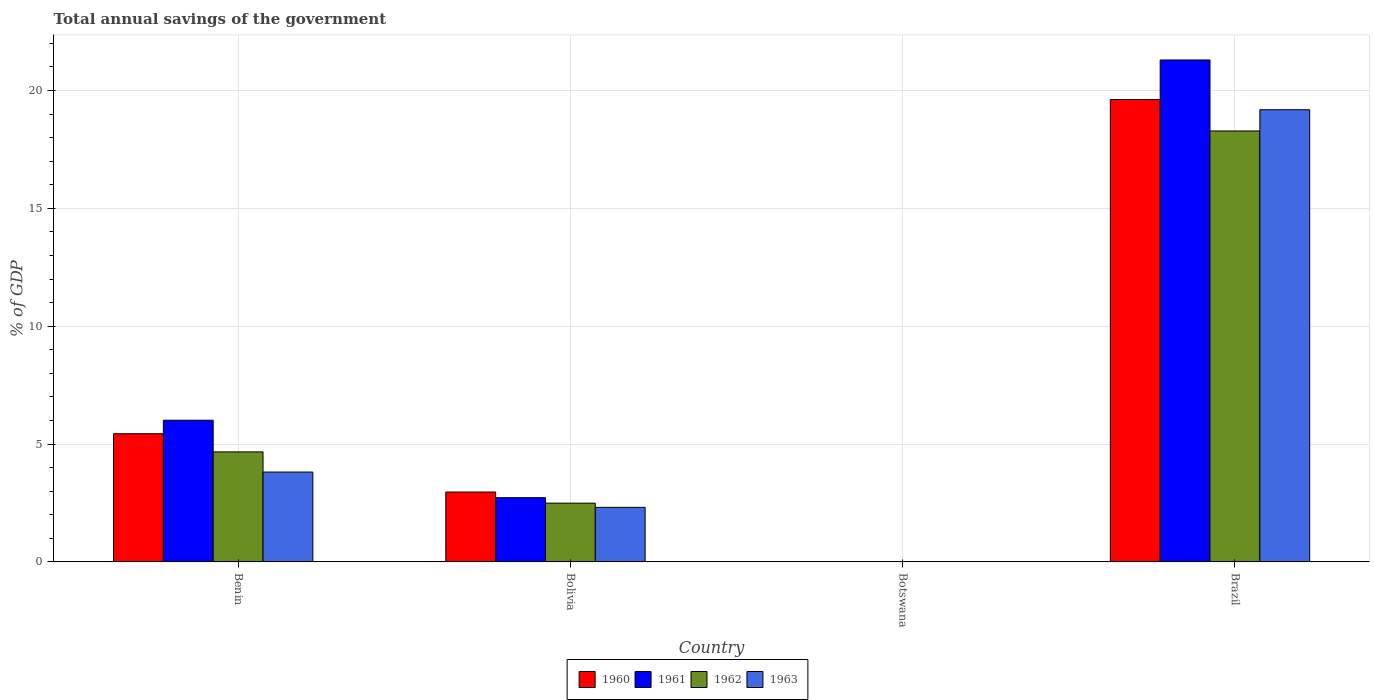Are the number of bars per tick equal to the number of legend labels?
Give a very brief answer. No. Are the number of bars on each tick of the X-axis equal?
Provide a short and direct response. No. How many bars are there on the 4th tick from the right?
Make the answer very short. 4. What is the label of the 1st group of bars from the left?
Your answer should be very brief. Benin. In how many cases, is the number of bars for a given country not equal to the number of legend labels?
Your answer should be very brief. 1. What is the total annual savings of the government in 1961 in Benin?
Ensure brevity in your answer.  6.01. Across all countries, what is the maximum total annual savings of the government in 1961?
Make the answer very short. 21.3. Across all countries, what is the minimum total annual savings of the government in 1960?
Your response must be concise. 0. In which country was the total annual savings of the government in 1963 maximum?
Make the answer very short. Brazil. What is the total total annual savings of the government in 1963 in the graph?
Your response must be concise. 25.31. What is the difference between the total annual savings of the government in 1962 in Benin and that in Brazil?
Offer a terse response. -13.62. What is the difference between the total annual savings of the government in 1961 in Benin and the total annual savings of the government in 1960 in Bolivia?
Ensure brevity in your answer.  3.05. What is the average total annual savings of the government in 1961 per country?
Give a very brief answer. 7.51. What is the difference between the total annual savings of the government of/in 1962 and total annual savings of the government of/in 1963 in Bolivia?
Your answer should be compact. 0.18. In how many countries, is the total annual savings of the government in 1962 greater than 21 %?
Ensure brevity in your answer.  0. What is the ratio of the total annual savings of the government in 1963 in Bolivia to that in Brazil?
Provide a short and direct response. 0.12. What is the difference between the highest and the second highest total annual savings of the government in 1962?
Make the answer very short. 15.79. What is the difference between the highest and the lowest total annual savings of the government in 1963?
Your response must be concise. 19.19. Is the sum of the total annual savings of the government in 1962 in Benin and Brazil greater than the maximum total annual savings of the government in 1961 across all countries?
Provide a succinct answer. Yes. Is it the case that in every country, the sum of the total annual savings of the government in 1962 and total annual savings of the government in 1961 is greater than the sum of total annual savings of the government in 1963 and total annual savings of the government in 1960?
Ensure brevity in your answer.  No. How many bars are there?
Offer a terse response. 12. Are all the bars in the graph horizontal?
Ensure brevity in your answer.  No. Are the values on the major ticks of Y-axis written in scientific E-notation?
Offer a very short reply. No. Does the graph contain any zero values?
Make the answer very short. Yes. Does the graph contain grids?
Your answer should be compact. Yes. Where does the legend appear in the graph?
Your answer should be compact. Bottom center. How many legend labels are there?
Keep it short and to the point. 4. What is the title of the graph?
Offer a very short reply. Total annual savings of the government. What is the label or title of the Y-axis?
Offer a very short reply. % of GDP. What is the % of GDP of 1960 in Benin?
Your response must be concise. 5.44. What is the % of GDP in 1961 in Benin?
Provide a short and direct response. 6.01. What is the % of GDP of 1962 in Benin?
Offer a very short reply. 4.67. What is the % of GDP of 1963 in Benin?
Make the answer very short. 3.81. What is the % of GDP in 1960 in Bolivia?
Keep it short and to the point. 2.96. What is the % of GDP of 1961 in Bolivia?
Your answer should be compact. 2.73. What is the % of GDP of 1962 in Bolivia?
Your answer should be compact. 2.49. What is the % of GDP in 1963 in Bolivia?
Your answer should be very brief. 2.32. What is the % of GDP of 1962 in Botswana?
Provide a short and direct response. 0. What is the % of GDP of 1963 in Botswana?
Keep it short and to the point. 0. What is the % of GDP of 1960 in Brazil?
Your response must be concise. 19.62. What is the % of GDP in 1961 in Brazil?
Provide a succinct answer. 21.3. What is the % of GDP in 1962 in Brazil?
Your answer should be compact. 18.28. What is the % of GDP of 1963 in Brazil?
Make the answer very short. 19.19. Across all countries, what is the maximum % of GDP of 1960?
Keep it short and to the point. 19.62. Across all countries, what is the maximum % of GDP in 1961?
Your answer should be very brief. 21.3. Across all countries, what is the maximum % of GDP of 1962?
Provide a succinct answer. 18.28. Across all countries, what is the maximum % of GDP of 1963?
Your response must be concise. 19.19. Across all countries, what is the minimum % of GDP of 1960?
Offer a terse response. 0. Across all countries, what is the minimum % of GDP in 1962?
Your response must be concise. 0. What is the total % of GDP in 1960 in the graph?
Keep it short and to the point. 28.02. What is the total % of GDP of 1961 in the graph?
Your answer should be very brief. 30.03. What is the total % of GDP in 1962 in the graph?
Your answer should be compact. 25.45. What is the total % of GDP in 1963 in the graph?
Offer a very short reply. 25.31. What is the difference between the % of GDP in 1960 in Benin and that in Bolivia?
Ensure brevity in your answer.  2.47. What is the difference between the % of GDP in 1961 in Benin and that in Bolivia?
Offer a terse response. 3.29. What is the difference between the % of GDP of 1962 in Benin and that in Bolivia?
Ensure brevity in your answer.  2.17. What is the difference between the % of GDP of 1963 in Benin and that in Bolivia?
Your answer should be very brief. 1.5. What is the difference between the % of GDP of 1960 in Benin and that in Brazil?
Your answer should be very brief. -14.18. What is the difference between the % of GDP of 1961 in Benin and that in Brazil?
Your response must be concise. -15.28. What is the difference between the % of GDP of 1962 in Benin and that in Brazil?
Your response must be concise. -13.62. What is the difference between the % of GDP in 1963 in Benin and that in Brazil?
Provide a short and direct response. -15.37. What is the difference between the % of GDP in 1960 in Bolivia and that in Brazil?
Your answer should be very brief. -16.66. What is the difference between the % of GDP in 1961 in Bolivia and that in Brazil?
Offer a terse response. -18.57. What is the difference between the % of GDP in 1962 in Bolivia and that in Brazil?
Your answer should be very brief. -15.79. What is the difference between the % of GDP in 1963 in Bolivia and that in Brazil?
Provide a short and direct response. -16.87. What is the difference between the % of GDP of 1960 in Benin and the % of GDP of 1961 in Bolivia?
Offer a very short reply. 2.71. What is the difference between the % of GDP of 1960 in Benin and the % of GDP of 1962 in Bolivia?
Your answer should be very brief. 2.95. What is the difference between the % of GDP of 1960 in Benin and the % of GDP of 1963 in Bolivia?
Provide a short and direct response. 3.12. What is the difference between the % of GDP of 1961 in Benin and the % of GDP of 1962 in Bolivia?
Offer a terse response. 3.52. What is the difference between the % of GDP of 1961 in Benin and the % of GDP of 1963 in Bolivia?
Provide a short and direct response. 3.7. What is the difference between the % of GDP of 1962 in Benin and the % of GDP of 1963 in Bolivia?
Offer a very short reply. 2.35. What is the difference between the % of GDP of 1960 in Benin and the % of GDP of 1961 in Brazil?
Provide a short and direct response. -15.86. What is the difference between the % of GDP in 1960 in Benin and the % of GDP in 1962 in Brazil?
Keep it short and to the point. -12.85. What is the difference between the % of GDP of 1960 in Benin and the % of GDP of 1963 in Brazil?
Offer a terse response. -13.75. What is the difference between the % of GDP of 1961 in Benin and the % of GDP of 1962 in Brazil?
Ensure brevity in your answer.  -12.27. What is the difference between the % of GDP in 1961 in Benin and the % of GDP in 1963 in Brazil?
Your answer should be compact. -13.17. What is the difference between the % of GDP of 1962 in Benin and the % of GDP of 1963 in Brazil?
Give a very brief answer. -14.52. What is the difference between the % of GDP of 1960 in Bolivia and the % of GDP of 1961 in Brazil?
Offer a terse response. -18.33. What is the difference between the % of GDP in 1960 in Bolivia and the % of GDP in 1962 in Brazil?
Your response must be concise. -15.32. What is the difference between the % of GDP of 1960 in Bolivia and the % of GDP of 1963 in Brazil?
Make the answer very short. -16.22. What is the difference between the % of GDP of 1961 in Bolivia and the % of GDP of 1962 in Brazil?
Your answer should be very brief. -15.56. What is the difference between the % of GDP of 1961 in Bolivia and the % of GDP of 1963 in Brazil?
Offer a terse response. -16.46. What is the difference between the % of GDP of 1962 in Bolivia and the % of GDP of 1963 in Brazil?
Offer a terse response. -16.69. What is the average % of GDP in 1960 per country?
Make the answer very short. 7.01. What is the average % of GDP of 1961 per country?
Keep it short and to the point. 7.51. What is the average % of GDP of 1962 per country?
Your response must be concise. 6.36. What is the average % of GDP of 1963 per country?
Make the answer very short. 6.33. What is the difference between the % of GDP of 1960 and % of GDP of 1961 in Benin?
Make the answer very short. -0.57. What is the difference between the % of GDP in 1960 and % of GDP in 1962 in Benin?
Make the answer very short. 0.77. What is the difference between the % of GDP in 1960 and % of GDP in 1963 in Benin?
Keep it short and to the point. 1.63. What is the difference between the % of GDP of 1961 and % of GDP of 1962 in Benin?
Give a very brief answer. 1.34. What is the difference between the % of GDP of 1961 and % of GDP of 1963 in Benin?
Provide a succinct answer. 2.2. What is the difference between the % of GDP of 1962 and % of GDP of 1963 in Benin?
Provide a short and direct response. 0.86. What is the difference between the % of GDP in 1960 and % of GDP in 1961 in Bolivia?
Your answer should be very brief. 0.24. What is the difference between the % of GDP of 1960 and % of GDP of 1962 in Bolivia?
Provide a short and direct response. 0.47. What is the difference between the % of GDP of 1960 and % of GDP of 1963 in Bolivia?
Make the answer very short. 0.65. What is the difference between the % of GDP in 1961 and % of GDP in 1962 in Bolivia?
Keep it short and to the point. 0.23. What is the difference between the % of GDP of 1961 and % of GDP of 1963 in Bolivia?
Provide a short and direct response. 0.41. What is the difference between the % of GDP of 1962 and % of GDP of 1963 in Bolivia?
Your answer should be compact. 0.18. What is the difference between the % of GDP in 1960 and % of GDP in 1961 in Brazil?
Your answer should be compact. -1.68. What is the difference between the % of GDP of 1960 and % of GDP of 1962 in Brazil?
Make the answer very short. 1.34. What is the difference between the % of GDP in 1960 and % of GDP in 1963 in Brazil?
Your answer should be very brief. 0.43. What is the difference between the % of GDP of 1961 and % of GDP of 1962 in Brazil?
Keep it short and to the point. 3.01. What is the difference between the % of GDP in 1961 and % of GDP in 1963 in Brazil?
Ensure brevity in your answer.  2.11. What is the difference between the % of GDP of 1962 and % of GDP of 1963 in Brazil?
Provide a short and direct response. -0.9. What is the ratio of the % of GDP of 1960 in Benin to that in Bolivia?
Keep it short and to the point. 1.83. What is the ratio of the % of GDP in 1961 in Benin to that in Bolivia?
Make the answer very short. 2.21. What is the ratio of the % of GDP of 1962 in Benin to that in Bolivia?
Ensure brevity in your answer.  1.87. What is the ratio of the % of GDP in 1963 in Benin to that in Bolivia?
Provide a short and direct response. 1.65. What is the ratio of the % of GDP in 1960 in Benin to that in Brazil?
Provide a succinct answer. 0.28. What is the ratio of the % of GDP of 1961 in Benin to that in Brazil?
Offer a terse response. 0.28. What is the ratio of the % of GDP in 1962 in Benin to that in Brazil?
Give a very brief answer. 0.26. What is the ratio of the % of GDP in 1963 in Benin to that in Brazil?
Ensure brevity in your answer.  0.2. What is the ratio of the % of GDP of 1960 in Bolivia to that in Brazil?
Your answer should be very brief. 0.15. What is the ratio of the % of GDP of 1961 in Bolivia to that in Brazil?
Provide a short and direct response. 0.13. What is the ratio of the % of GDP in 1962 in Bolivia to that in Brazil?
Keep it short and to the point. 0.14. What is the ratio of the % of GDP in 1963 in Bolivia to that in Brazil?
Offer a very short reply. 0.12. What is the difference between the highest and the second highest % of GDP of 1960?
Provide a short and direct response. 14.18. What is the difference between the highest and the second highest % of GDP of 1961?
Provide a succinct answer. 15.28. What is the difference between the highest and the second highest % of GDP in 1962?
Make the answer very short. 13.62. What is the difference between the highest and the second highest % of GDP of 1963?
Provide a succinct answer. 15.37. What is the difference between the highest and the lowest % of GDP of 1960?
Your answer should be very brief. 19.62. What is the difference between the highest and the lowest % of GDP of 1961?
Your response must be concise. 21.3. What is the difference between the highest and the lowest % of GDP in 1962?
Ensure brevity in your answer.  18.28. What is the difference between the highest and the lowest % of GDP in 1963?
Offer a very short reply. 19.19. 